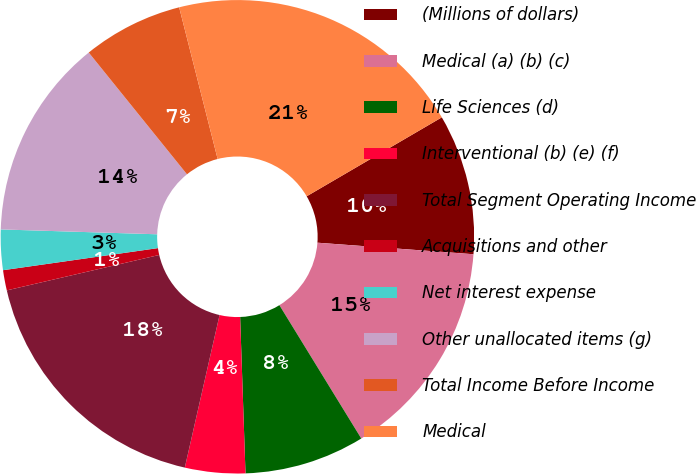Convert chart to OTSL. <chart><loc_0><loc_0><loc_500><loc_500><pie_chart><fcel>(Millions of dollars)<fcel>Medical (a) (b) (c)<fcel>Life Sciences (d)<fcel>Interventional (b) (e) (f)<fcel>Total Segment Operating Income<fcel>Acquisitions and other<fcel>Net interest expense<fcel>Other unallocated items (g)<fcel>Total Income Before Income<fcel>Medical<nl><fcel>9.59%<fcel>15.06%<fcel>8.22%<fcel>4.11%<fcel>17.8%<fcel>1.38%<fcel>2.75%<fcel>13.7%<fcel>6.85%<fcel>20.54%<nl></chart> 